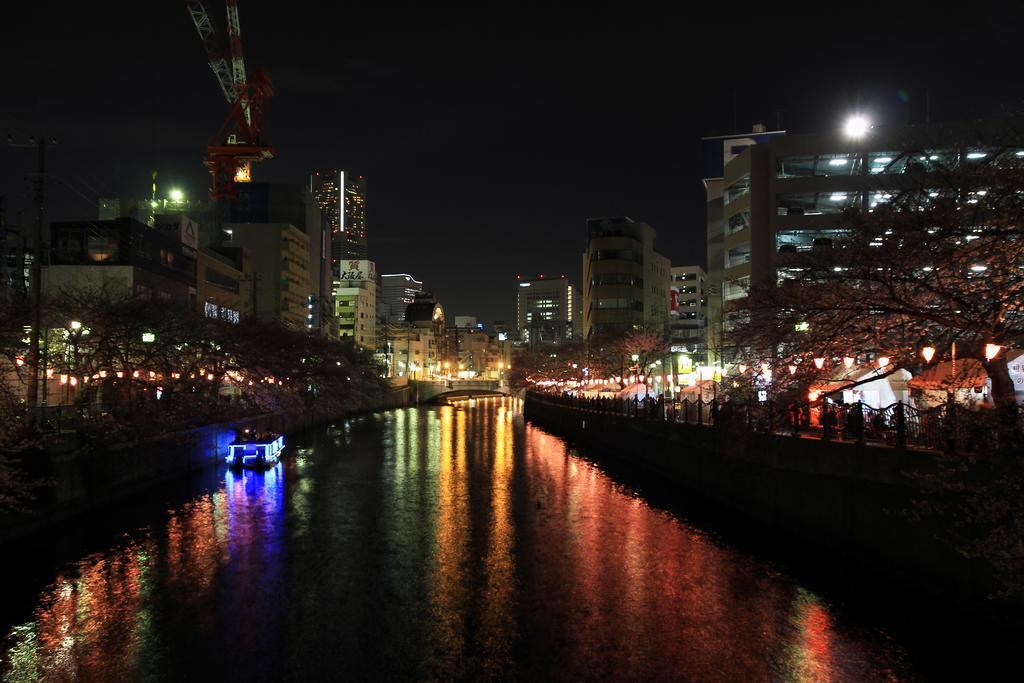Can you describe this image briefly? In this image there is the water. On the either sides of the water there is a railing. Behind the railing there are trees and light poles. In the background there are buildings. At the top there is the sky. There is a boat on the water. 